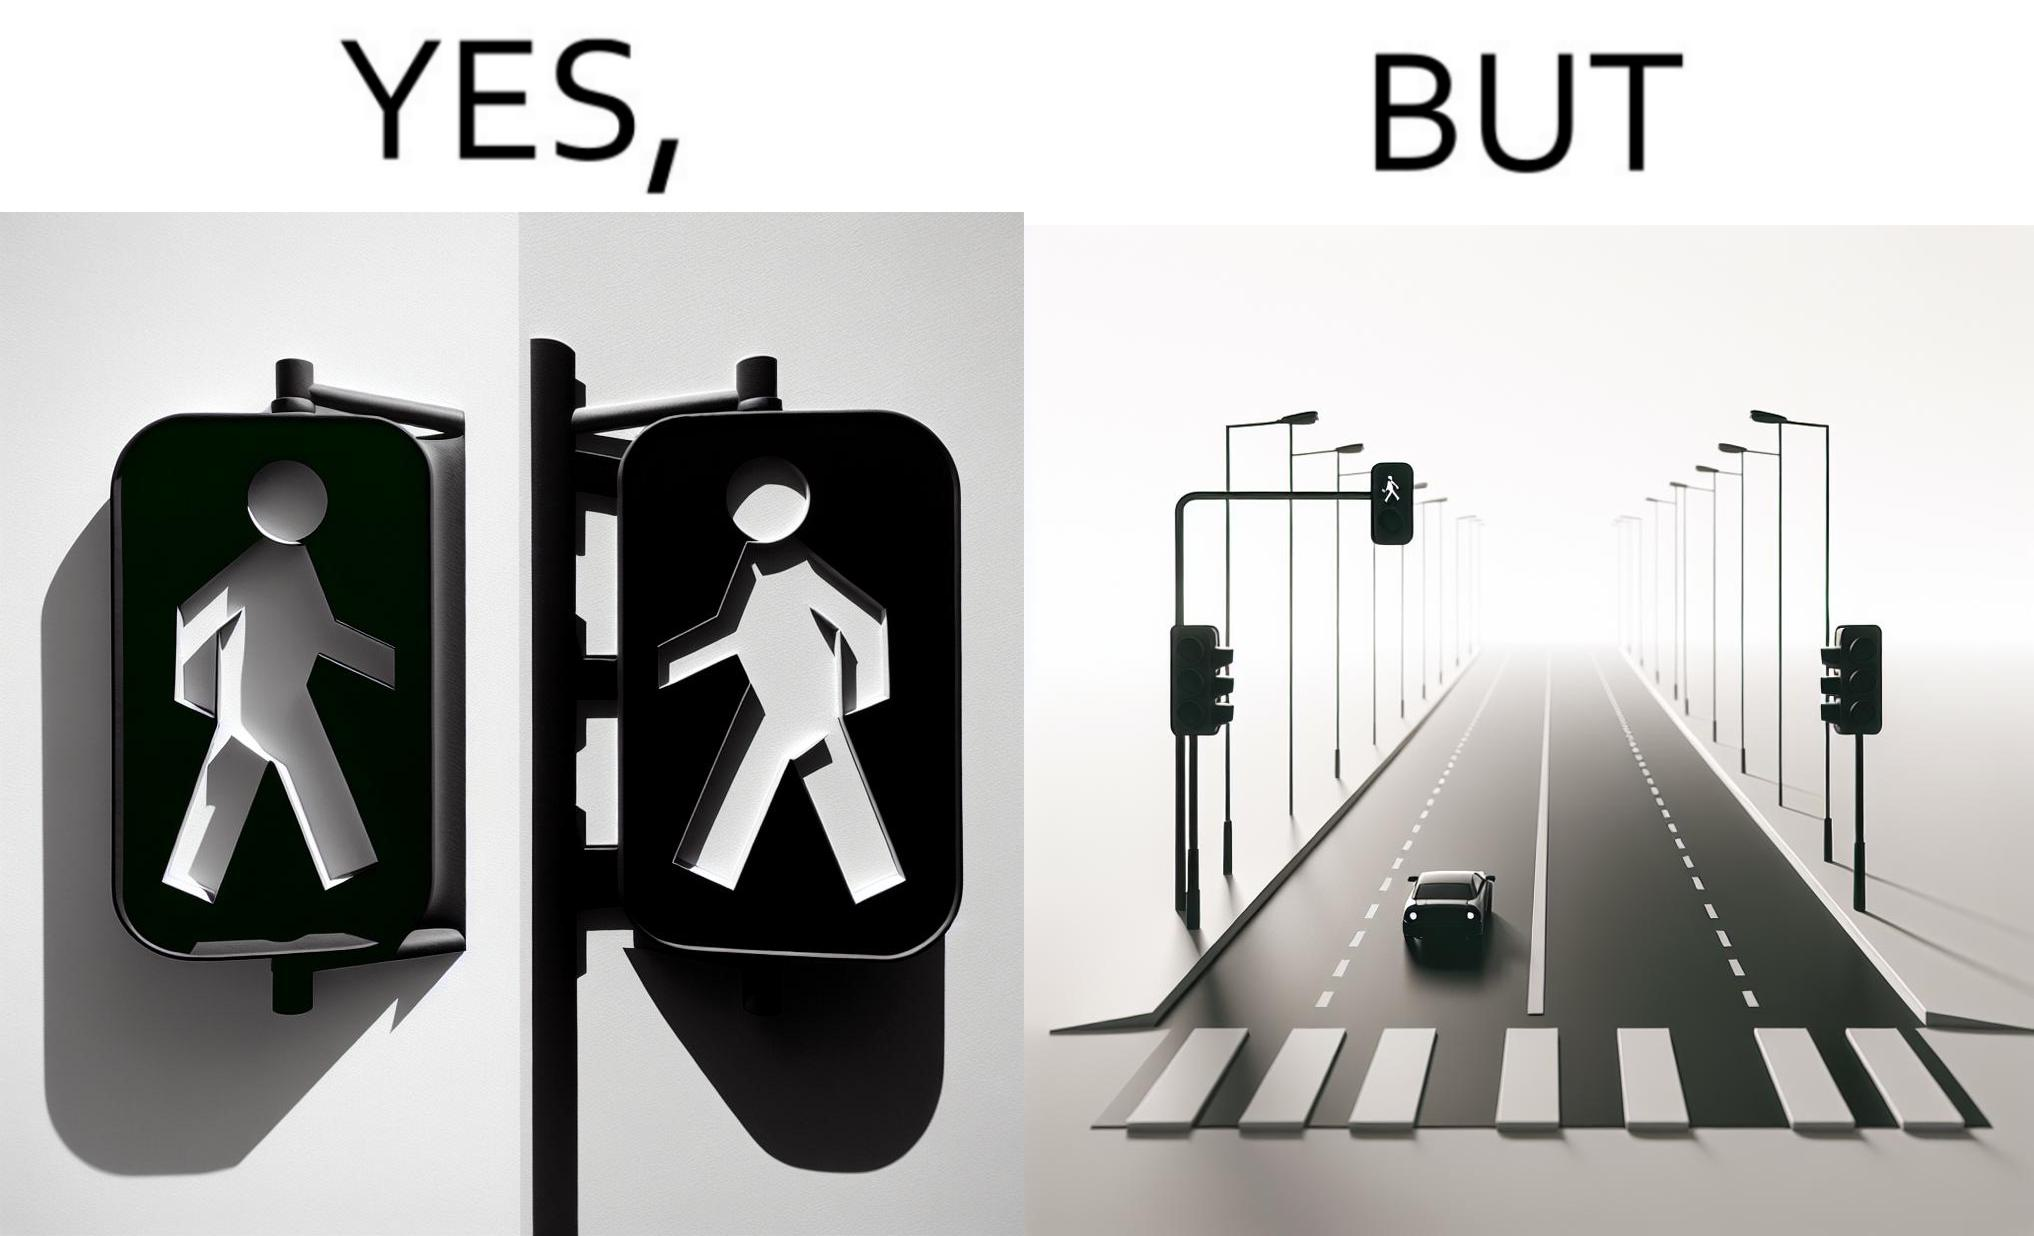Compare the left and right sides of this image. In the left part of the image: The image shows the walk sign turned to green on a traffic signal. In the right part of the image: The image shows an empty road with only one car on the road. The car is waiting for the walk sign to turn to red so that it can cross the zebra crossing.  There is no one else on the road except from the car. 